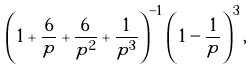<formula> <loc_0><loc_0><loc_500><loc_500>\left ( 1 + \frac { 6 } { p } + \frac { 6 } { p ^ { 2 } } + \frac { 1 } { p ^ { 3 } } \right ) ^ { - 1 } \left ( 1 - \frac { 1 } { p } \right ) ^ { 3 } ,</formula> 